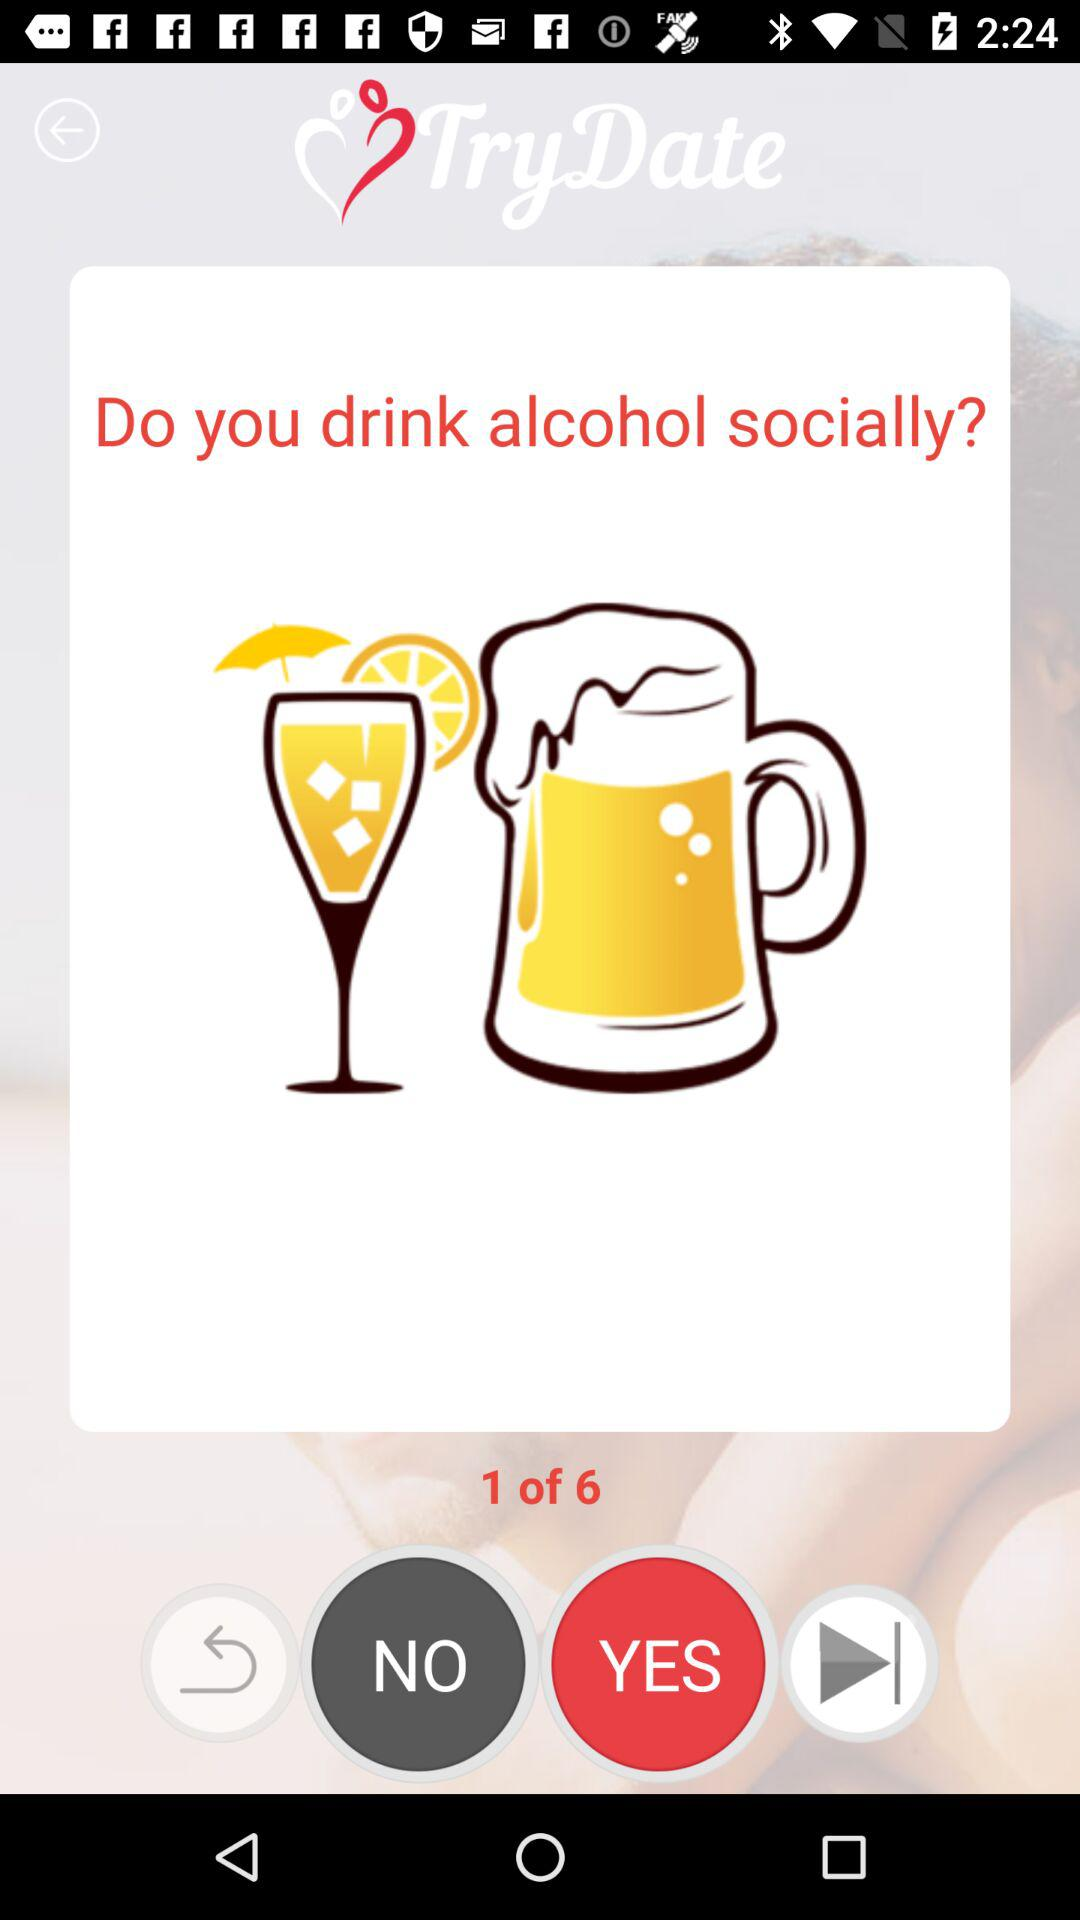Which question am I on? You are on question 1. 